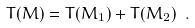Convert formula to latex. <formula><loc_0><loc_0><loc_500><loc_500>T ( M ) = T ( M _ { 1 } ) + T ( M _ { 2 } ) \ .</formula> 